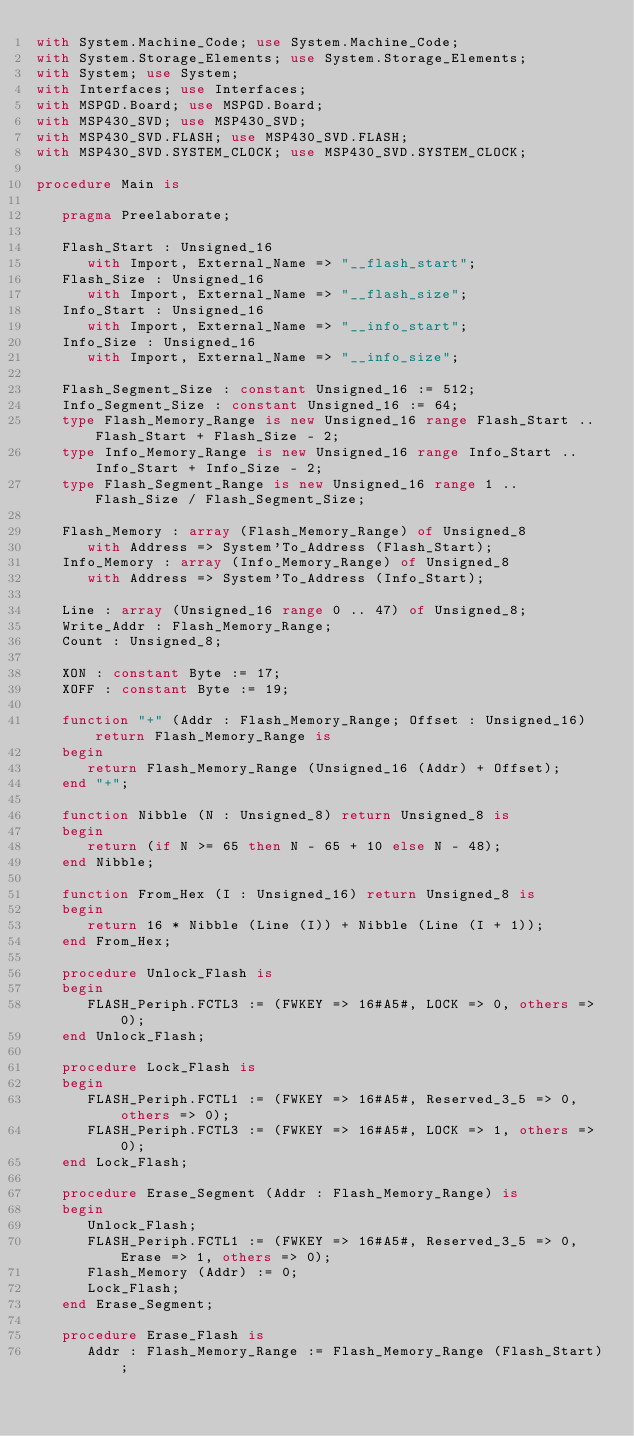Convert code to text. <code><loc_0><loc_0><loc_500><loc_500><_Ada_>with System.Machine_Code; use System.Machine_Code;
with System.Storage_Elements; use System.Storage_Elements;
with System; use System;
with Interfaces; use Interfaces;
with MSPGD.Board; use MSPGD.Board;
with MSP430_SVD; use MSP430_SVD;
with MSP430_SVD.FLASH; use MSP430_SVD.FLASH;
with MSP430_SVD.SYSTEM_CLOCK; use MSP430_SVD.SYSTEM_CLOCK;

procedure Main is

   pragma Preelaborate;

   Flash_Start : Unsigned_16
      with Import, External_Name => "__flash_start";
   Flash_Size : Unsigned_16
      with Import, External_Name => "__flash_size";
   Info_Start : Unsigned_16
      with Import, External_Name => "__info_start";
   Info_Size : Unsigned_16
      with Import, External_Name => "__info_size";

   Flash_Segment_Size : constant Unsigned_16 := 512;
   Info_Segment_Size : constant Unsigned_16 := 64;
   type Flash_Memory_Range is new Unsigned_16 range Flash_Start .. Flash_Start + Flash_Size - 2;
   type Info_Memory_Range is new Unsigned_16 range Info_Start .. Info_Start + Info_Size - 2;
   type Flash_Segment_Range is new Unsigned_16 range 1 .. Flash_Size / Flash_Segment_Size;

   Flash_Memory : array (Flash_Memory_Range) of Unsigned_8
      with Address => System'To_Address (Flash_Start);
   Info_Memory : array (Info_Memory_Range) of Unsigned_8
      with Address => System'To_Address (Info_Start);

   Line : array (Unsigned_16 range 0 .. 47) of Unsigned_8;
   Write_Addr : Flash_Memory_Range;
   Count : Unsigned_8;

   XON : constant Byte := 17;
   XOFF : constant Byte := 19;

   function "+" (Addr : Flash_Memory_Range; Offset : Unsigned_16) return Flash_Memory_Range is
   begin
      return Flash_Memory_Range (Unsigned_16 (Addr) + Offset);
   end "+";

   function Nibble (N : Unsigned_8) return Unsigned_8 is
   begin
      return (if N >= 65 then N - 65 + 10 else N - 48);
   end Nibble;

   function From_Hex (I : Unsigned_16) return Unsigned_8 is
   begin
      return 16 * Nibble (Line (I)) + Nibble (Line (I + 1));
   end From_Hex;

   procedure Unlock_Flash is
   begin
      FLASH_Periph.FCTL3 := (FWKEY => 16#A5#, LOCK => 0, others => 0);
   end Unlock_Flash;

   procedure Lock_Flash is
   begin
      FLASH_Periph.FCTL1 := (FWKEY => 16#A5#, Reserved_3_5 => 0, others => 0);
      FLASH_Periph.FCTL3 := (FWKEY => 16#A5#, LOCK => 1, others => 0);
   end Lock_Flash;

   procedure Erase_Segment (Addr : Flash_Memory_Range) is
   begin
      Unlock_Flash;
      FLASH_Periph.FCTL1 := (FWKEY => 16#A5#, Reserved_3_5 => 0, Erase => 1, others => 0);
      Flash_Memory (Addr) := 0;
      Lock_Flash;
   end Erase_Segment;

   procedure Erase_Flash is
      Addr : Flash_Memory_Range := Flash_Memory_Range (Flash_Start);</code> 